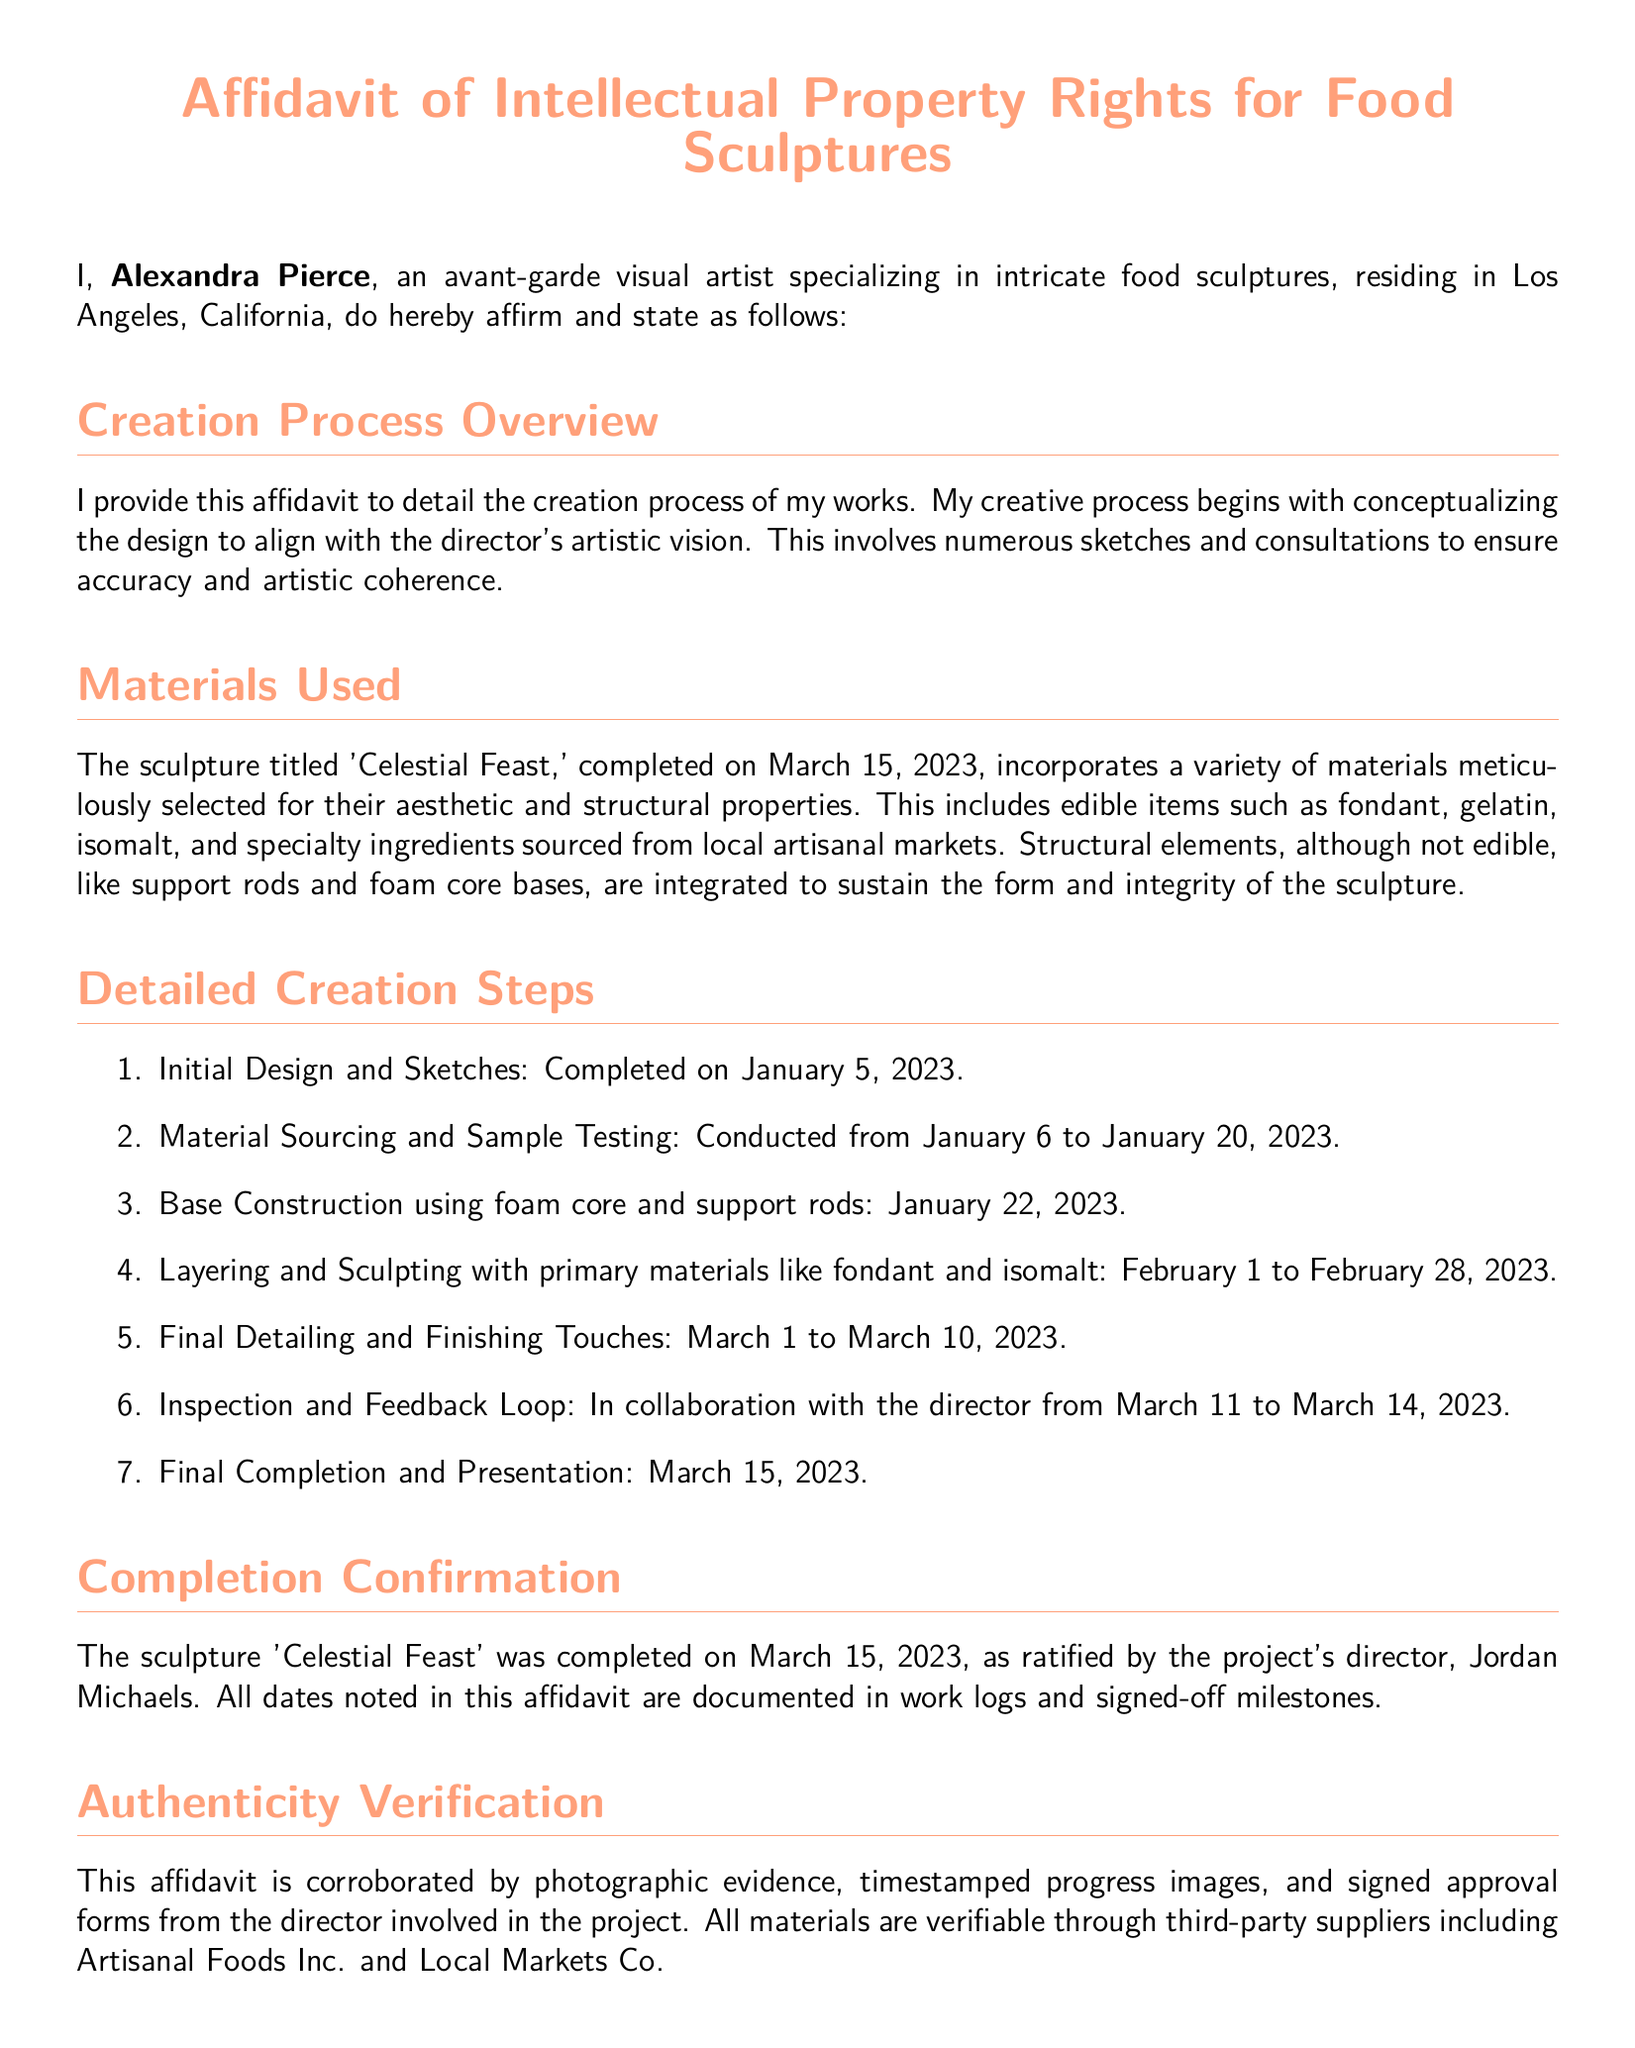What is the title of the sculpture? The title 'Celestial Feast' is mentioned as the work created by Alexandra Pierce.
Answer: Celestial Feast Who is the artist? The affidavit identifies Alexandra Pierce as the artist responsible for the food sculptures.
Answer: Alexandra Pierce What is the completion date of the sculpture? The document states that the sculpture was completed on March 15, 2023.
Answer: March 15, 2023 What materials were primarily used in the sculpture? Fondant and isomalt are specified as the primary materials in the creation of the sculpture.
Answer: Fondant, isomalt How long did the layering and sculpting process take? Layering and sculpting occurred from February 1 to February 28, 2023, which is 28 days.
Answer: 28 days What is the name of the director involved in the project? The affidavit mentions Jordan Michaels as the director associated with the sculpture.
Answer: Jordan Michaels What is detailed in the section on Creation Process Overview? This section outlines the initial stages of conceptualizing and designing to align with the director's vision.
Answer: Conceptualizing design What company provided the materials? The affidavit references Artisanal Foods Inc. and Local Markets Co. as suppliers for the materials.
Answer: Artisanal Foods Inc., Local Markets Co What formal statement does the artist make at the end of the document? The declaration confirms that the statements in the affidavit are true and correct under the penalty of perjury.
Answer: True and correct 